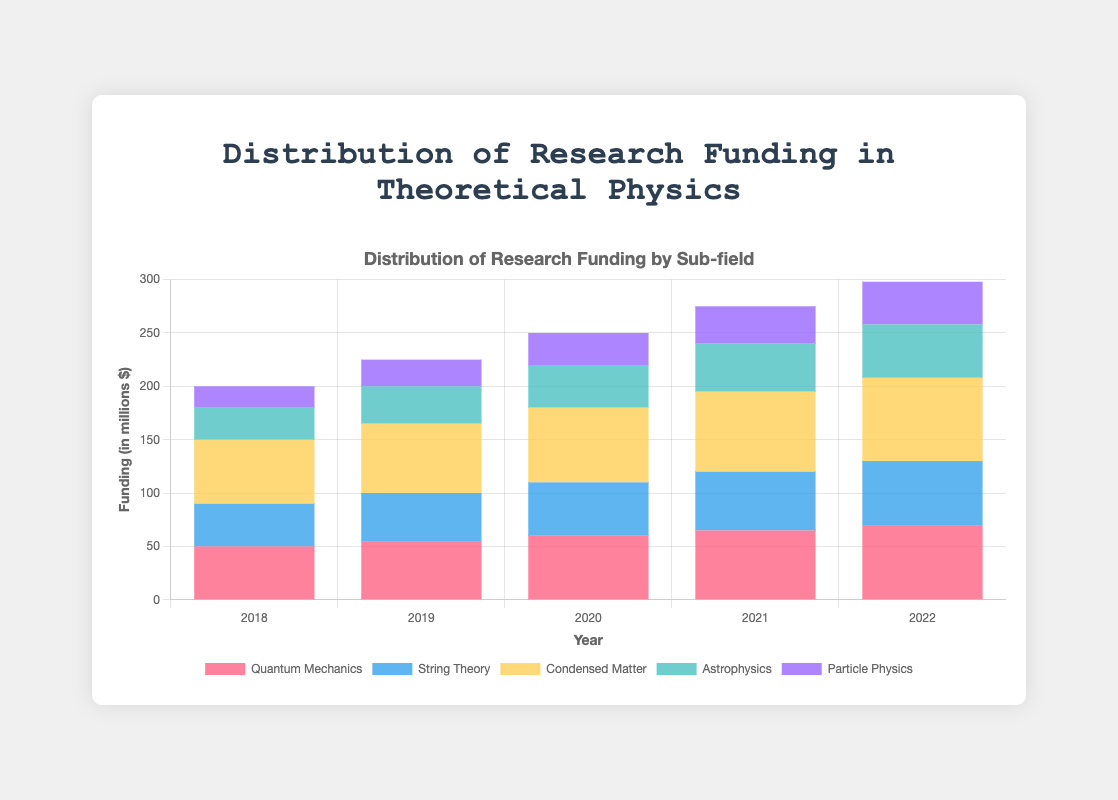What is the total funding for Condensed Matter and Astrophysics in 2022? Condensed Matter funding in 2022 is 78 million and Astrophysics is 50 million. Summing those gives 78 + 50 = 128 million.
Answer: 128 million Which sub-field consistently received increasing funding from 2018 to 2022? By examining the heights of the bars over the years, we can see that Quantum Mechanics funding increases every year from 50 in 2018 to 70 in 2022.
Answer: Quantum Mechanics By how much did the funding for String Theory increase from 2018 to 2019? In 2018, String Theory funding was 40 million and in 2019, it increased to 45 million. So, the difference is 45 - 40 = 5 million.
Answer: 5 million Which year had the highest overall funding for theoretical physics research? By visually summing the heights of the bars for each year, 2022 has the highest overall funding. It can be confirmed by adding the individual amounts for 2022, which is the highest total sum compared to other years.
Answer: 2022 Did the funding for Particle Physics ever equal the funding for Condensed Matter in any year? By comparing the heights of the respective bars for Particle Physics and Condensed Matter across all years, no year shows equal funding for both sub-fields.
Answer: No What is the difference in funding between the highest and lowest funded sub-fields in 2021? The highest funded sub-field in 2021 is Condensed Matter with 75 million, and the lowest is Particle Physics with 35 million. The difference is 75 - 35 = 40 million.
Answer: 40 million In 2020, is the funding for Quantum Mechanics greater than the combined funding for Astrophysics and Particle Physics? In 2020, Quantum Mechanics funding is 60 million. Combined funding for Astrophysics and Particle Physics is 40 + 30 = 70 million. 60 million is less than 70 million.
Answer: No Which sub-field has the lowest funding in 2019? Looking at the bars for 2019, Particle Physics has the lowest funding with 25 million.
Answer: Particle Physics If we average the annual funding for String Theory from 2018 to 2022, what is the result? Sum of funding for String Theory from 2018-2022 is 40 + 45 + 50 + 55 + 60 = 250 million. Dividing by 5 years gives 250 / 5 = 50 million.
Answer: 50 million What is the visual difference in the heights of the bars for Quantum Mechanics in 2019 and 2020? In 2019, Quantum Mechanics is 55 million, and in 2020 it's 60 million. The visual height difference is 60 - 55 = 5 million.
Answer: 5 million 